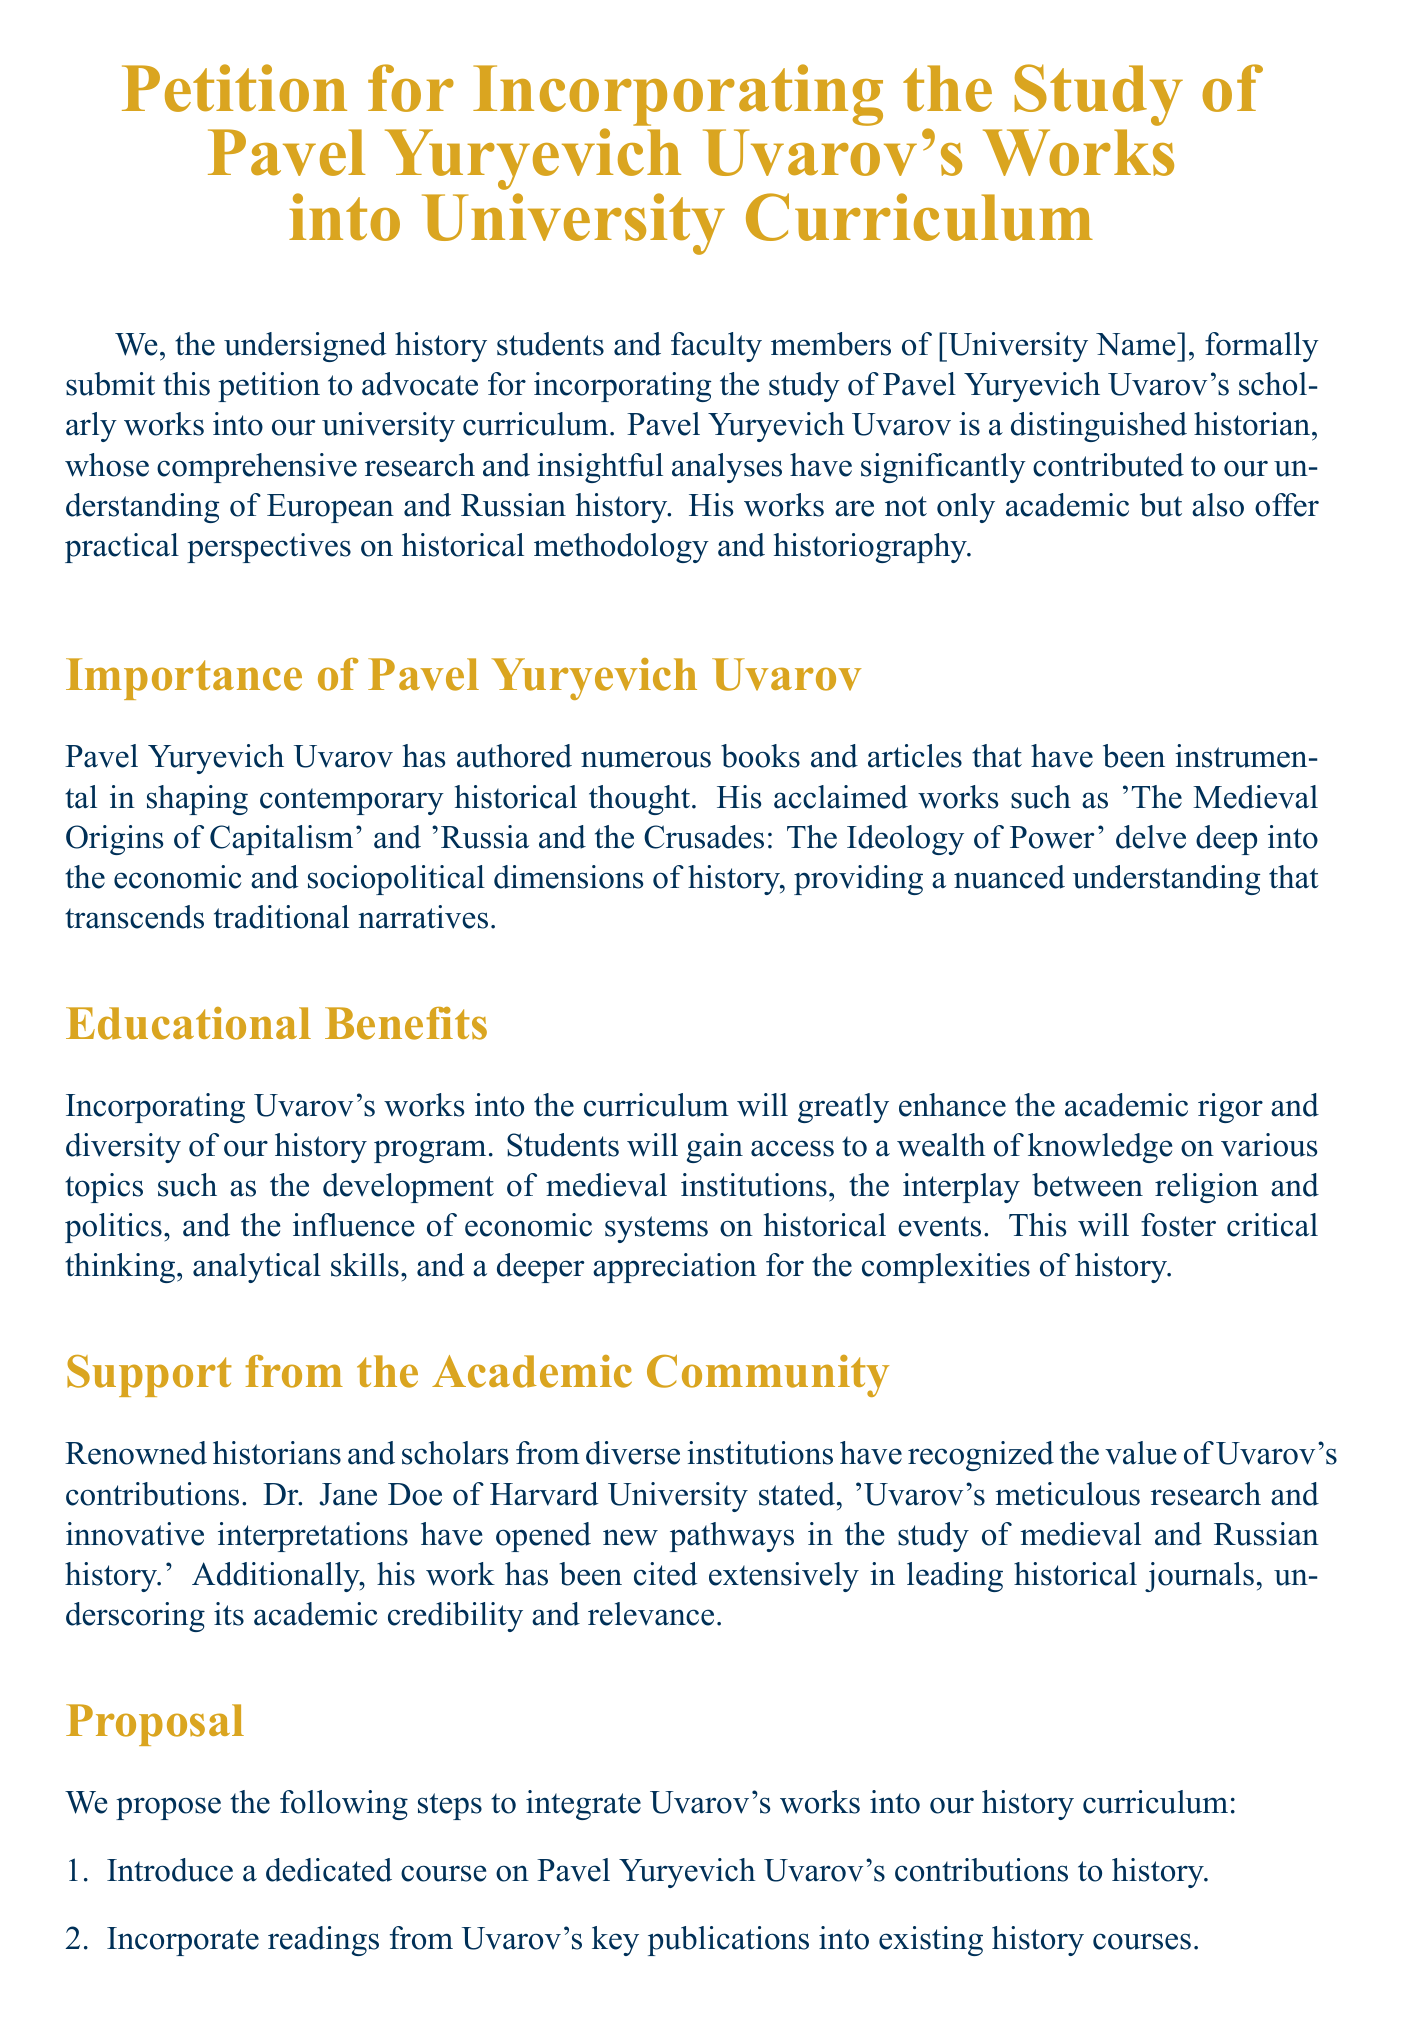What is the title of the petition? The title of the petition is prominently displayed in the document as "Petition for Incorporating the Study of Pavel Yuryevich Uvarov's Works into University Curriculum."
Answer: Petition for Incorporating the Study of Pavel Yuryevich Uvarov's Works into University Curriculum Who is Pavel Yuryevich Uvarov? He is described in the petition as a distinguished historian whose research has contributed to the understanding of European and Russian history.
Answer: A distinguished historian What are two of Uvarov's notable works mentioned? The document lists 'The Medieval Origins of Capitalism' and 'Russia and the Crusades: The Ideology of Power' as notable works.
Answer: The Medieval Origins of Capitalism, Russia and the Crusades: The Ideology of Power How many proposals are listed for integrating Uvarov's works into the curriculum? The document enumerates four specific proposals.
Answer: Four What is one benefit of incorporating Uvarov's works into the curriculum? The document mentions enhancing academic rigor and diversity as a benefit of incorporating his works.
Answer: Enhance academic rigor and diversity Which institution is Dr. Jane Doe affiliated with? The document states that Dr. Jane Doe is affiliated with Harvard University.
Answer: Harvard University What title does Michael Brown hold? Michael Brown is identified in the document as a Graduate Student in the Department of History.
Answer: Graduate Student, Department of History What is the significance of Uvarov's contributions according to the petition? The petition cites that Uvarov's contributions have opened new pathways in the study of medieval and Russian history.
Answer: Opened new pathways in the study of medieval and Russian history 